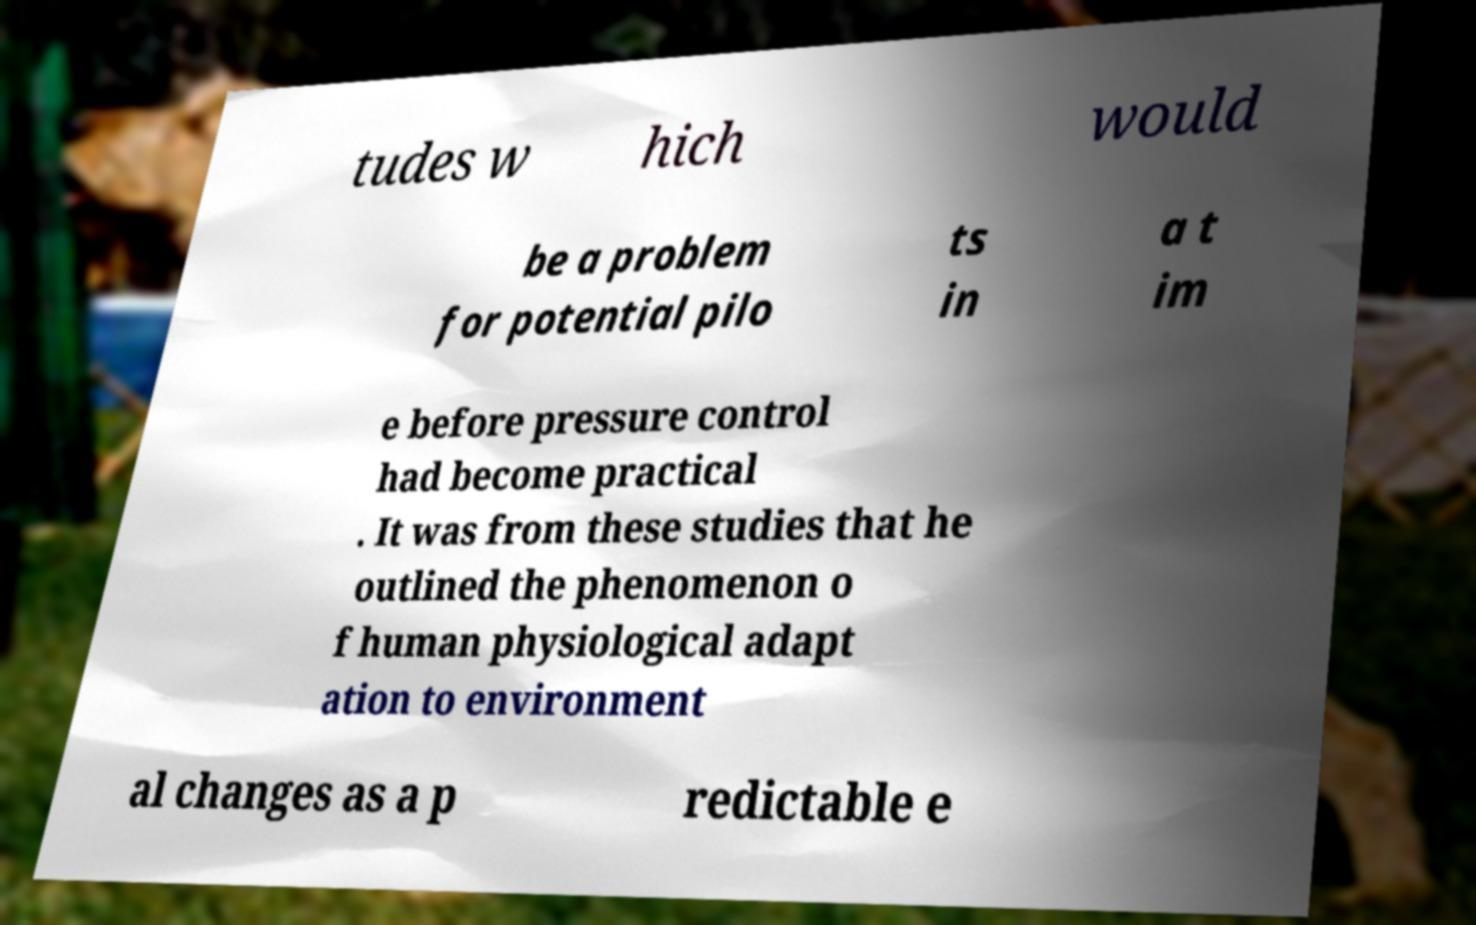Can you read and provide the text displayed in the image?This photo seems to have some interesting text. Can you extract and type it out for me? tudes w hich would be a problem for potential pilo ts in a t im e before pressure control had become practical . It was from these studies that he outlined the phenomenon o f human physiological adapt ation to environment al changes as a p redictable e 